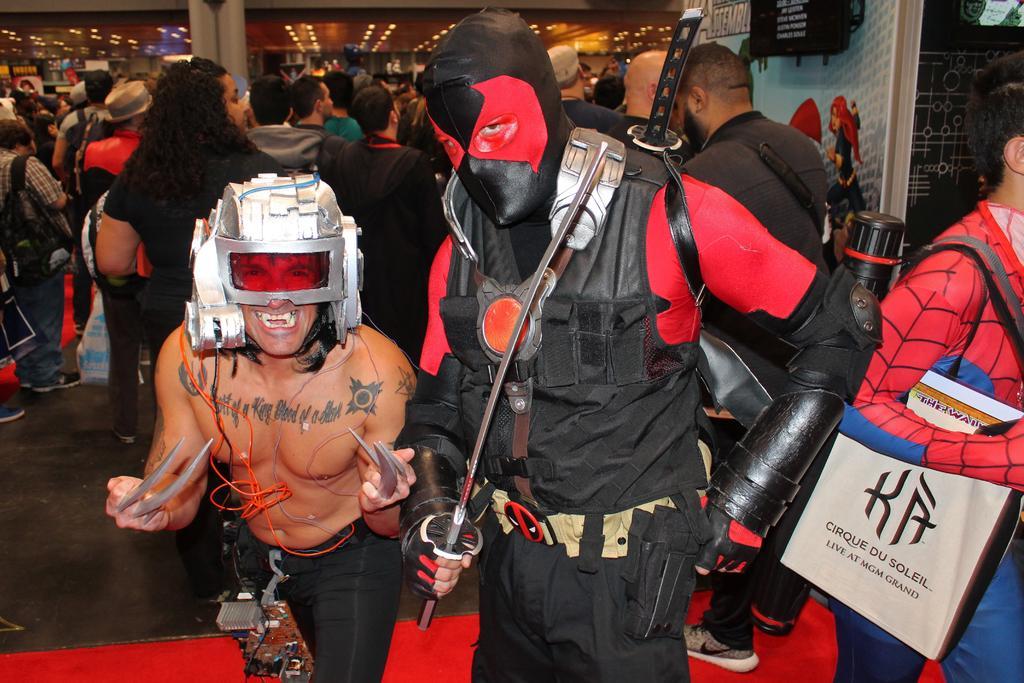Please provide a concise description of this image. In the picture we can see many people in the hall some of them are in different costumes and to the ceiling of his hall we can see many lights and besides we can see the wall with some cartoon paintings on it. 